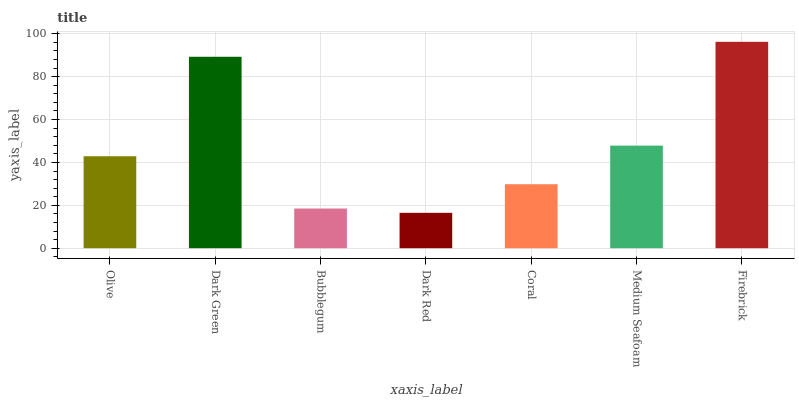Is Dark Red the minimum?
Answer yes or no. Yes. Is Firebrick the maximum?
Answer yes or no. Yes. Is Dark Green the minimum?
Answer yes or no. No. Is Dark Green the maximum?
Answer yes or no. No. Is Dark Green greater than Olive?
Answer yes or no. Yes. Is Olive less than Dark Green?
Answer yes or no. Yes. Is Olive greater than Dark Green?
Answer yes or no. No. Is Dark Green less than Olive?
Answer yes or no. No. Is Olive the high median?
Answer yes or no. Yes. Is Olive the low median?
Answer yes or no. Yes. Is Firebrick the high median?
Answer yes or no. No. Is Dark Green the low median?
Answer yes or no. No. 